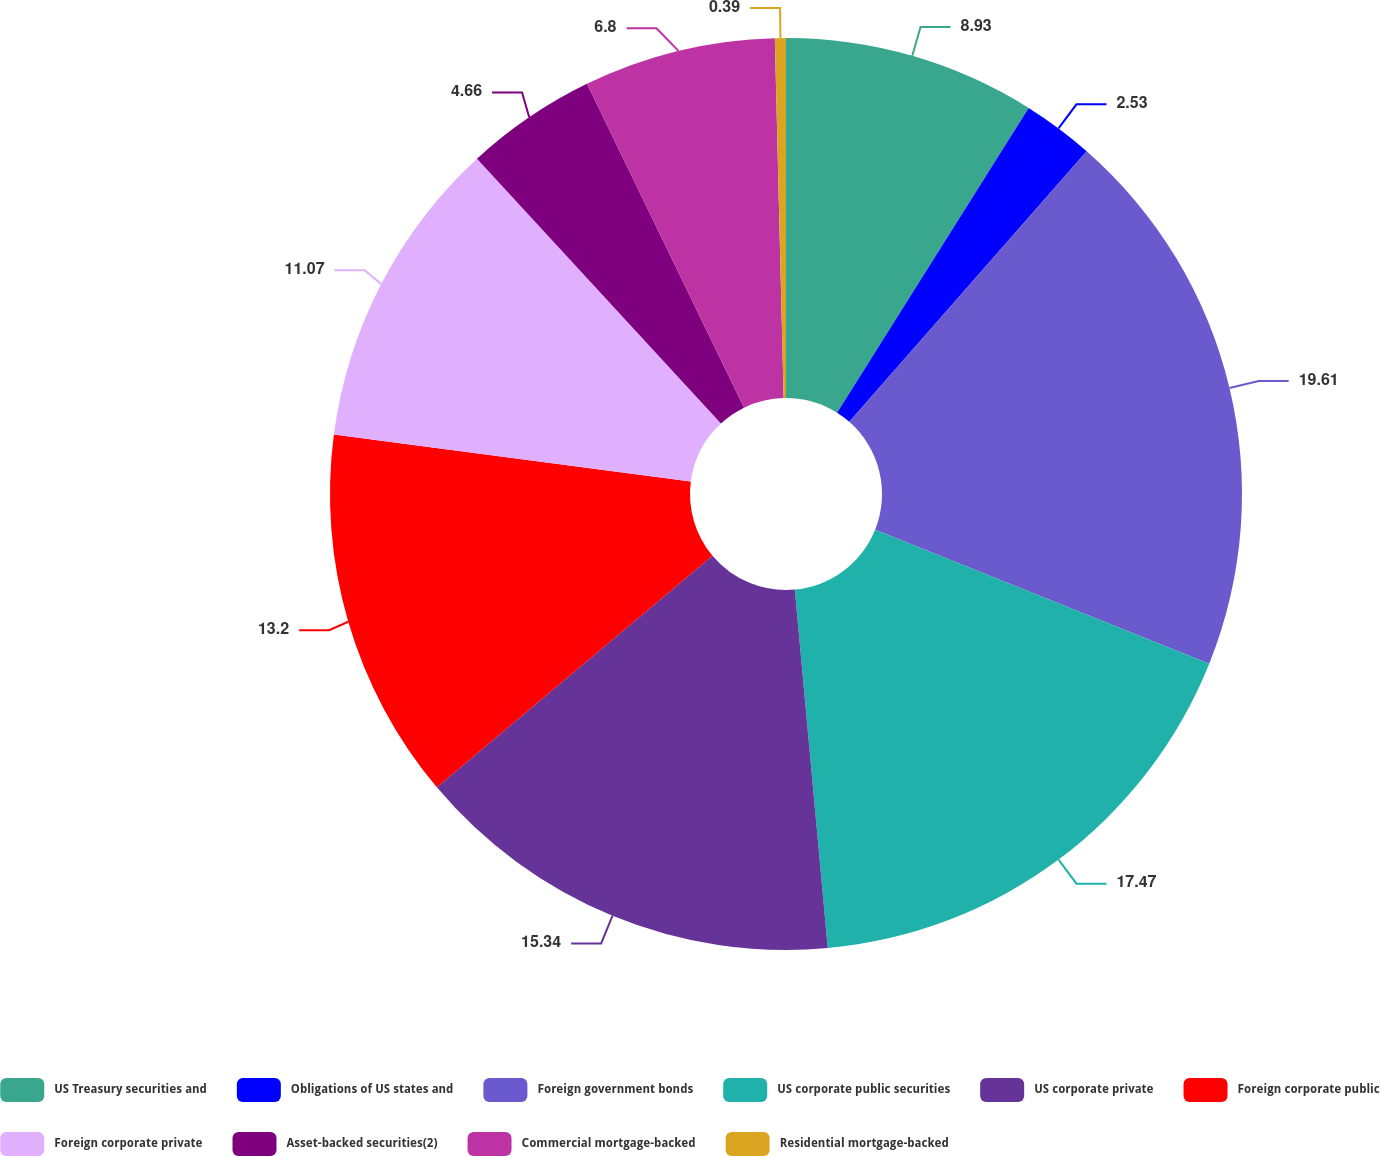Convert chart to OTSL. <chart><loc_0><loc_0><loc_500><loc_500><pie_chart><fcel>US Treasury securities and<fcel>Obligations of US states and<fcel>Foreign government bonds<fcel>US corporate public securities<fcel>US corporate private<fcel>Foreign corporate public<fcel>Foreign corporate private<fcel>Asset-backed securities(2)<fcel>Commercial mortgage-backed<fcel>Residential mortgage-backed<nl><fcel>8.93%<fcel>2.53%<fcel>19.61%<fcel>17.47%<fcel>15.34%<fcel>13.2%<fcel>11.07%<fcel>4.66%<fcel>6.8%<fcel>0.39%<nl></chart> 